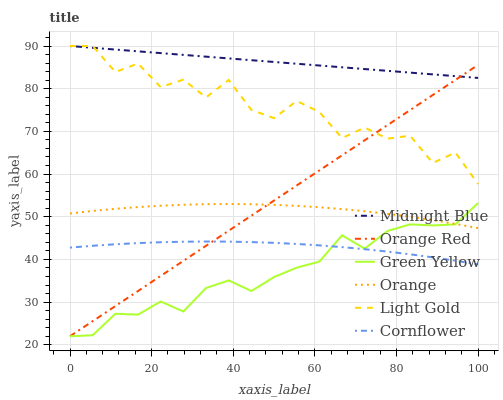Does Green Yellow have the minimum area under the curve?
Answer yes or no. Yes. Does Midnight Blue have the maximum area under the curve?
Answer yes or no. Yes. Does Orange have the minimum area under the curve?
Answer yes or no. No. Does Orange have the maximum area under the curve?
Answer yes or no. No. Is Midnight Blue the smoothest?
Answer yes or no. Yes. Is Light Gold the roughest?
Answer yes or no. Yes. Is Orange the smoothest?
Answer yes or no. No. Is Orange the roughest?
Answer yes or no. No. Does Orange have the lowest value?
Answer yes or no. No. Does Light Gold have the highest value?
Answer yes or no. Yes. Does Orange have the highest value?
Answer yes or no. No. Is Orange less than Midnight Blue?
Answer yes or no. Yes. Is Orange greater than Cornflower?
Answer yes or no. Yes. Does Midnight Blue intersect Light Gold?
Answer yes or no. Yes. Is Midnight Blue less than Light Gold?
Answer yes or no. No. Is Midnight Blue greater than Light Gold?
Answer yes or no. No. Does Orange intersect Midnight Blue?
Answer yes or no. No. 